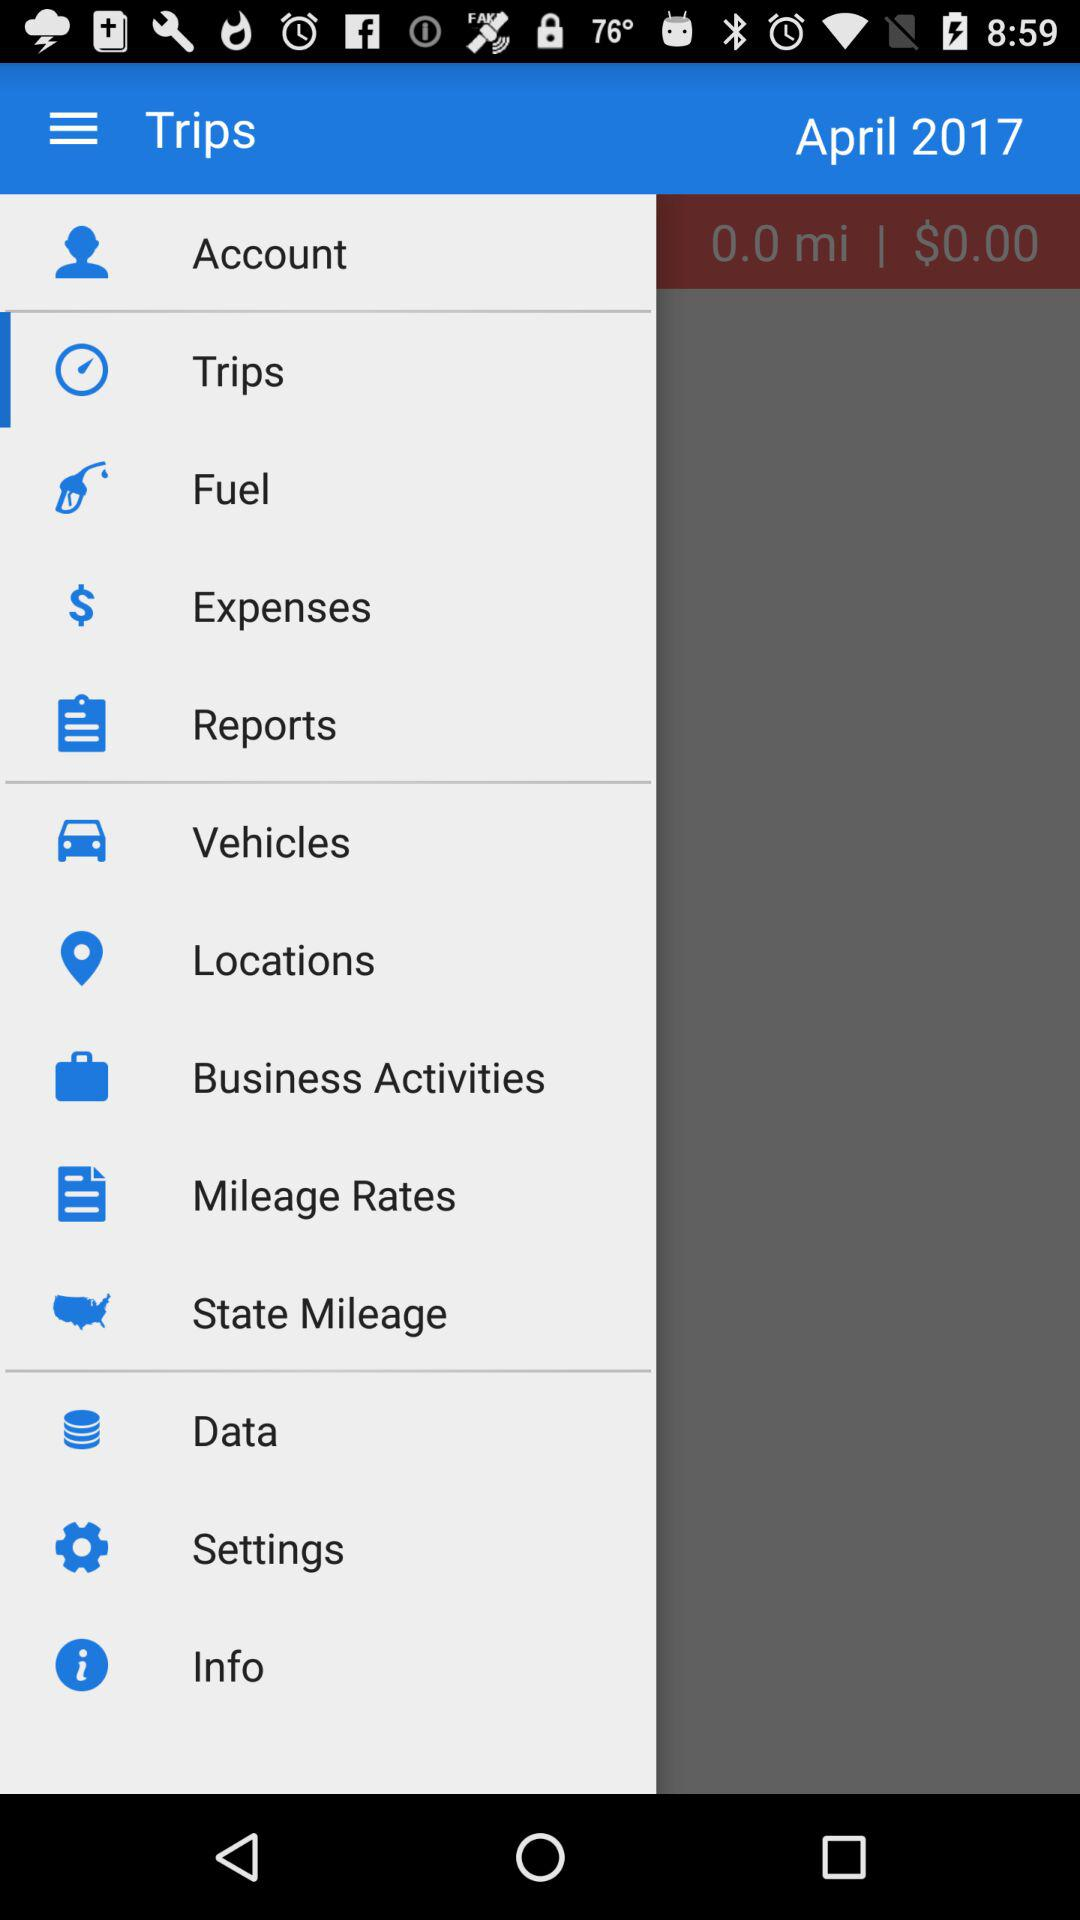What is the mentioned year? The mentioned year is 2017. 